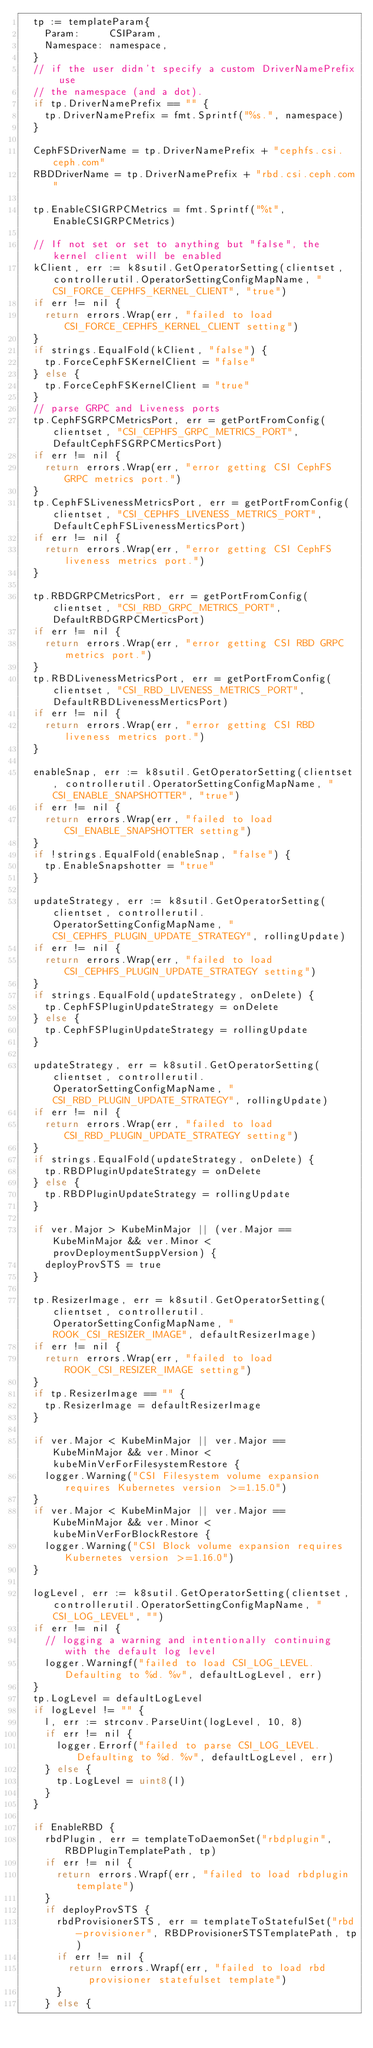Convert code to text. <code><loc_0><loc_0><loc_500><loc_500><_Go_>	tp := templateParam{
		Param:     CSIParam,
		Namespace: namespace,
	}
	// if the user didn't specify a custom DriverNamePrefix use
	// the namespace (and a dot).
	if tp.DriverNamePrefix == "" {
		tp.DriverNamePrefix = fmt.Sprintf("%s.", namespace)
	}

	CephFSDriverName = tp.DriverNamePrefix + "cephfs.csi.ceph.com"
	RBDDriverName = tp.DriverNamePrefix + "rbd.csi.ceph.com"

	tp.EnableCSIGRPCMetrics = fmt.Sprintf("%t", EnableCSIGRPCMetrics)

	// If not set or set to anything but "false", the kernel client will be enabled
	kClient, err := k8sutil.GetOperatorSetting(clientset, controllerutil.OperatorSettingConfigMapName, "CSI_FORCE_CEPHFS_KERNEL_CLIENT", "true")
	if err != nil {
		return errors.Wrap(err, "failed to load CSI_FORCE_CEPHFS_KERNEL_CLIENT setting")
	}
	if strings.EqualFold(kClient, "false") {
		tp.ForceCephFSKernelClient = "false"
	} else {
		tp.ForceCephFSKernelClient = "true"
	}
	// parse GRPC and Liveness ports
	tp.CephFSGRPCMetricsPort, err = getPortFromConfig(clientset, "CSI_CEPHFS_GRPC_METRICS_PORT", DefaultCephFSGRPCMerticsPort)
	if err != nil {
		return errors.Wrap(err, "error getting CSI CephFS GRPC metrics port.")
	}
	tp.CephFSLivenessMetricsPort, err = getPortFromConfig(clientset, "CSI_CEPHFS_LIVENESS_METRICS_PORT", DefaultCephFSLivenessMerticsPort)
	if err != nil {
		return errors.Wrap(err, "error getting CSI CephFS liveness metrics port.")
	}

	tp.RBDGRPCMetricsPort, err = getPortFromConfig(clientset, "CSI_RBD_GRPC_METRICS_PORT", DefaultRBDGRPCMerticsPort)
	if err != nil {
		return errors.Wrap(err, "error getting CSI RBD GRPC metrics port.")
	}
	tp.RBDLivenessMetricsPort, err = getPortFromConfig(clientset, "CSI_RBD_LIVENESS_METRICS_PORT", DefaultRBDLivenessMerticsPort)
	if err != nil {
		return errors.Wrap(err, "error getting CSI RBD liveness metrics port.")
	}

	enableSnap, err := k8sutil.GetOperatorSetting(clientset, controllerutil.OperatorSettingConfigMapName, "CSI_ENABLE_SNAPSHOTTER", "true")
	if err != nil {
		return errors.Wrap(err, "failed to load CSI_ENABLE_SNAPSHOTTER setting")
	}
	if !strings.EqualFold(enableSnap, "false") {
		tp.EnableSnapshotter = "true"
	}

	updateStrategy, err := k8sutil.GetOperatorSetting(clientset, controllerutil.OperatorSettingConfigMapName, "CSI_CEPHFS_PLUGIN_UPDATE_STRATEGY", rollingUpdate)
	if err != nil {
		return errors.Wrap(err, "failed to load CSI_CEPHFS_PLUGIN_UPDATE_STRATEGY setting")
	}
	if strings.EqualFold(updateStrategy, onDelete) {
		tp.CephFSPluginUpdateStrategy = onDelete
	} else {
		tp.CephFSPluginUpdateStrategy = rollingUpdate
	}

	updateStrategy, err = k8sutil.GetOperatorSetting(clientset, controllerutil.OperatorSettingConfigMapName, "CSI_RBD_PLUGIN_UPDATE_STRATEGY", rollingUpdate)
	if err != nil {
		return errors.Wrap(err, "failed to load CSI_RBD_PLUGIN_UPDATE_STRATEGY setting")
	}
	if strings.EqualFold(updateStrategy, onDelete) {
		tp.RBDPluginUpdateStrategy = onDelete
	} else {
		tp.RBDPluginUpdateStrategy = rollingUpdate
	}

	if ver.Major > KubeMinMajor || (ver.Major == KubeMinMajor && ver.Minor < provDeploymentSuppVersion) {
		deployProvSTS = true
	}

	tp.ResizerImage, err = k8sutil.GetOperatorSetting(clientset, controllerutil.OperatorSettingConfigMapName, "ROOK_CSI_RESIZER_IMAGE", defaultResizerImage)
	if err != nil {
		return errors.Wrap(err, "failed to load ROOK_CSI_RESIZER_IMAGE setting")
	}
	if tp.ResizerImage == "" {
		tp.ResizerImage = defaultResizerImage
	}

	if ver.Major < KubeMinMajor || ver.Major == KubeMinMajor && ver.Minor < kubeMinVerForFilesystemRestore {
		logger.Warning("CSI Filesystem volume expansion requires Kubernetes version >=1.15.0")
	}
	if ver.Major < KubeMinMajor || ver.Major == KubeMinMajor && ver.Minor < kubeMinVerForBlockRestore {
		logger.Warning("CSI Block volume expansion requires Kubernetes version >=1.16.0")
	}

	logLevel, err := k8sutil.GetOperatorSetting(clientset, controllerutil.OperatorSettingConfigMapName, "CSI_LOG_LEVEL", "")
	if err != nil {
		// logging a warning and intentionally continuing with the default log level
		logger.Warningf("failed to load CSI_LOG_LEVEL. Defaulting to %d. %v", defaultLogLevel, err)
	}
	tp.LogLevel = defaultLogLevel
	if logLevel != "" {
		l, err := strconv.ParseUint(logLevel, 10, 8)
		if err != nil {
			logger.Errorf("failed to parse CSI_LOG_LEVEL. Defaulting to %d. %v", defaultLogLevel, err)
		} else {
			tp.LogLevel = uint8(l)
		}
	}

	if EnableRBD {
		rbdPlugin, err = templateToDaemonSet("rbdplugin", RBDPluginTemplatePath, tp)
		if err != nil {
			return errors.Wrapf(err, "failed to load rbdplugin template")
		}
		if deployProvSTS {
			rbdProvisionerSTS, err = templateToStatefulSet("rbd-provisioner", RBDProvisionerSTSTemplatePath, tp)
			if err != nil {
				return errors.Wrapf(err, "failed to load rbd provisioner statefulset template")
			}
		} else {</code> 